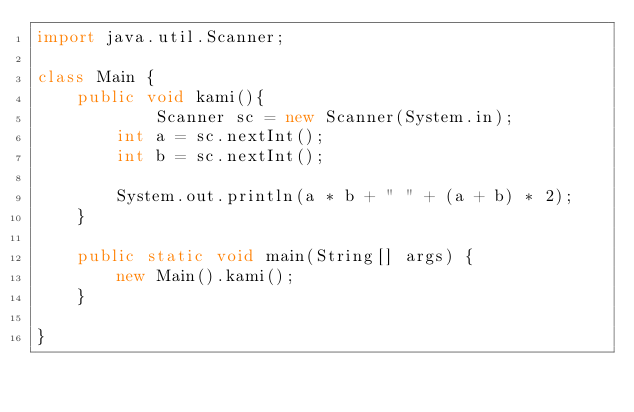Convert code to text. <code><loc_0><loc_0><loc_500><loc_500><_Java_>import java.util.Scanner;

class Main {
    public void kami(){
            Scanner sc = new Scanner(System.in);
        int a = sc.nextInt();
        int b = sc.nextInt();
        
        System.out.println(a * b + " " + (a + b) * 2);   
    }

    public static void main(String[] args) {
        new Main().kami();
    }

}</code> 